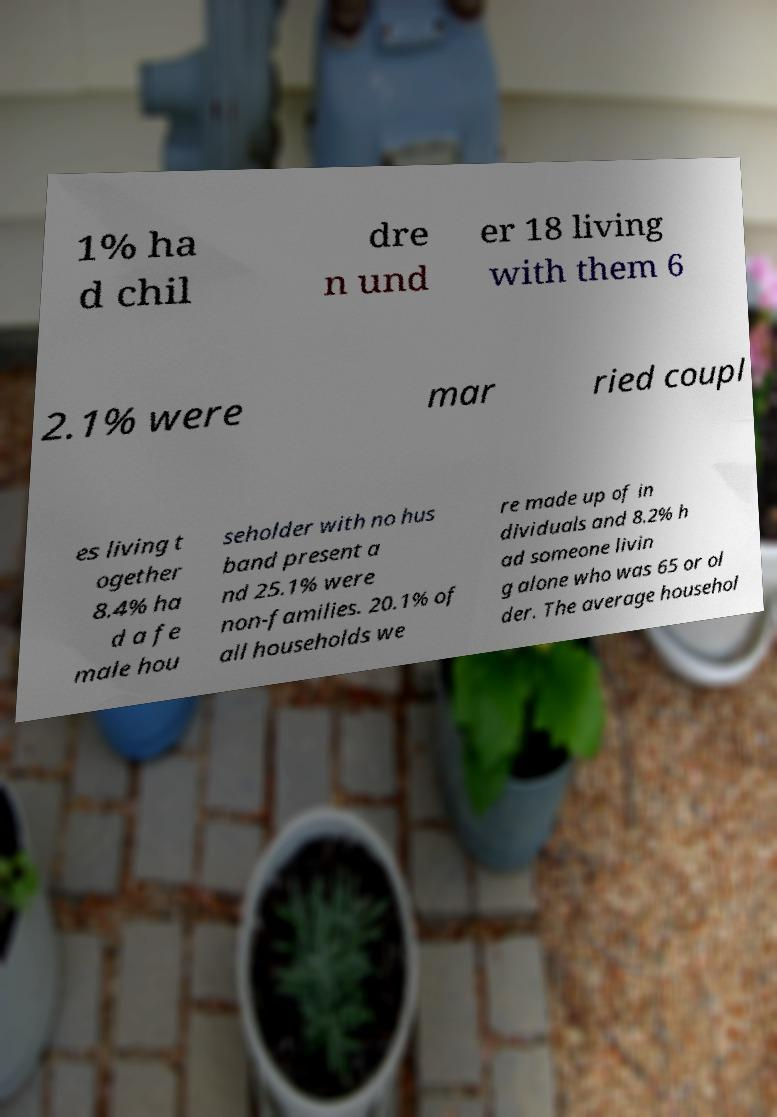Please identify and transcribe the text found in this image. 1% ha d chil dre n und er 18 living with them 6 2.1% were mar ried coupl es living t ogether 8.4% ha d a fe male hou seholder with no hus band present a nd 25.1% were non-families. 20.1% of all households we re made up of in dividuals and 8.2% h ad someone livin g alone who was 65 or ol der. The average househol 